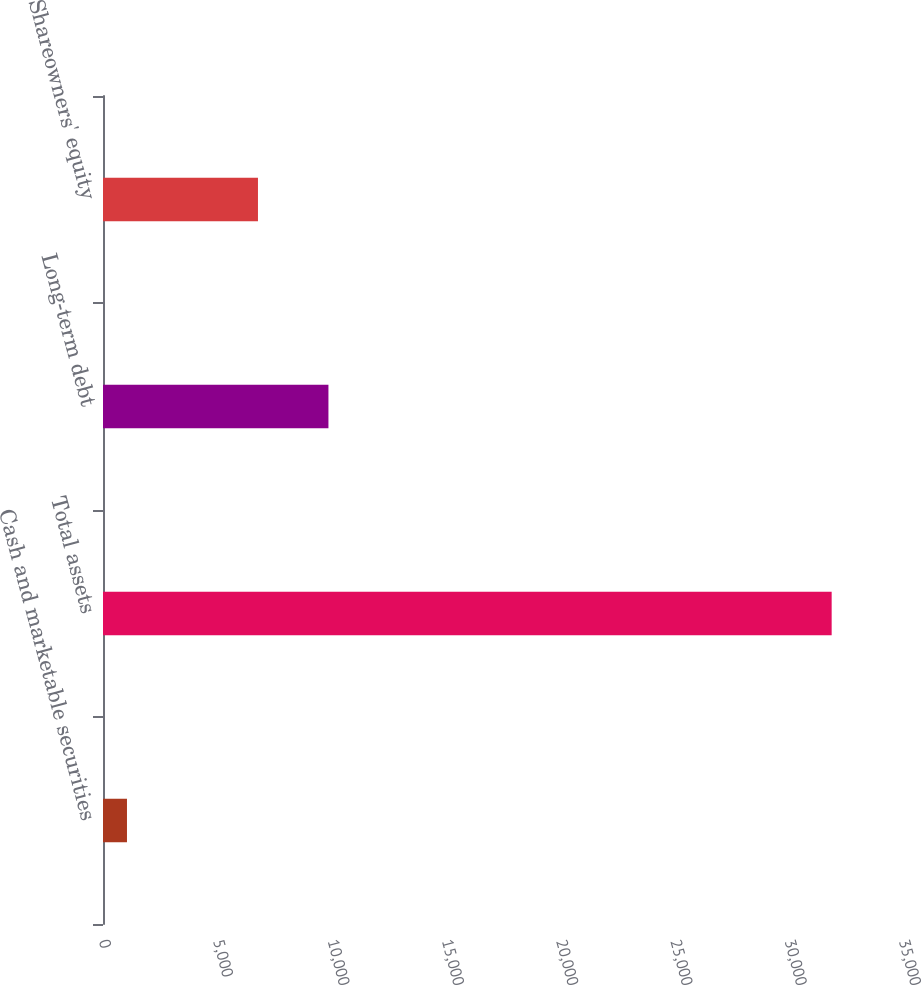Convert chart to OTSL. <chart><loc_0><loc_0><loc_500><loc_500><bar_chart><fcel>Cash and marketable securities<fcel>Total assets<fcel>Long-term debt<fcel>Shareowners' equity<nl><fcel>1049<fcel>31879<fcel>9863<fcel>6780<nl></chart> 